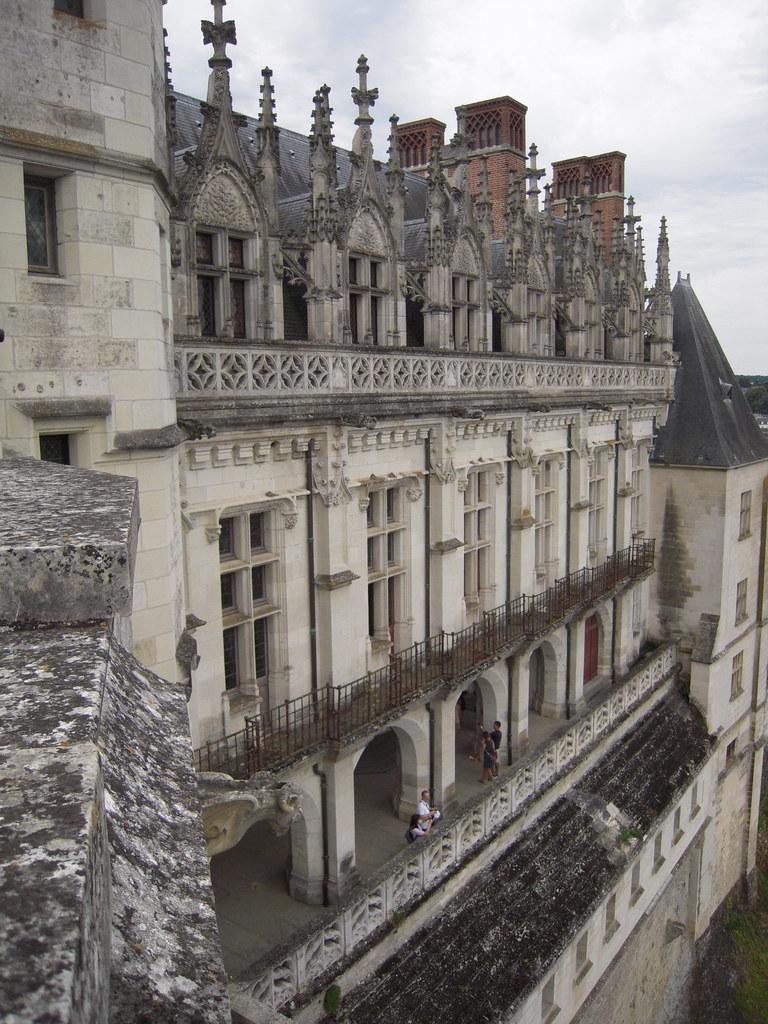Could you give a brief overview of what you see in this image? This image is taken outdoors. At the top of the image there is a sky with clouds. In this image there is a building with walls, windows, doors, arches, pillars, railings, sculptures and carvings. 